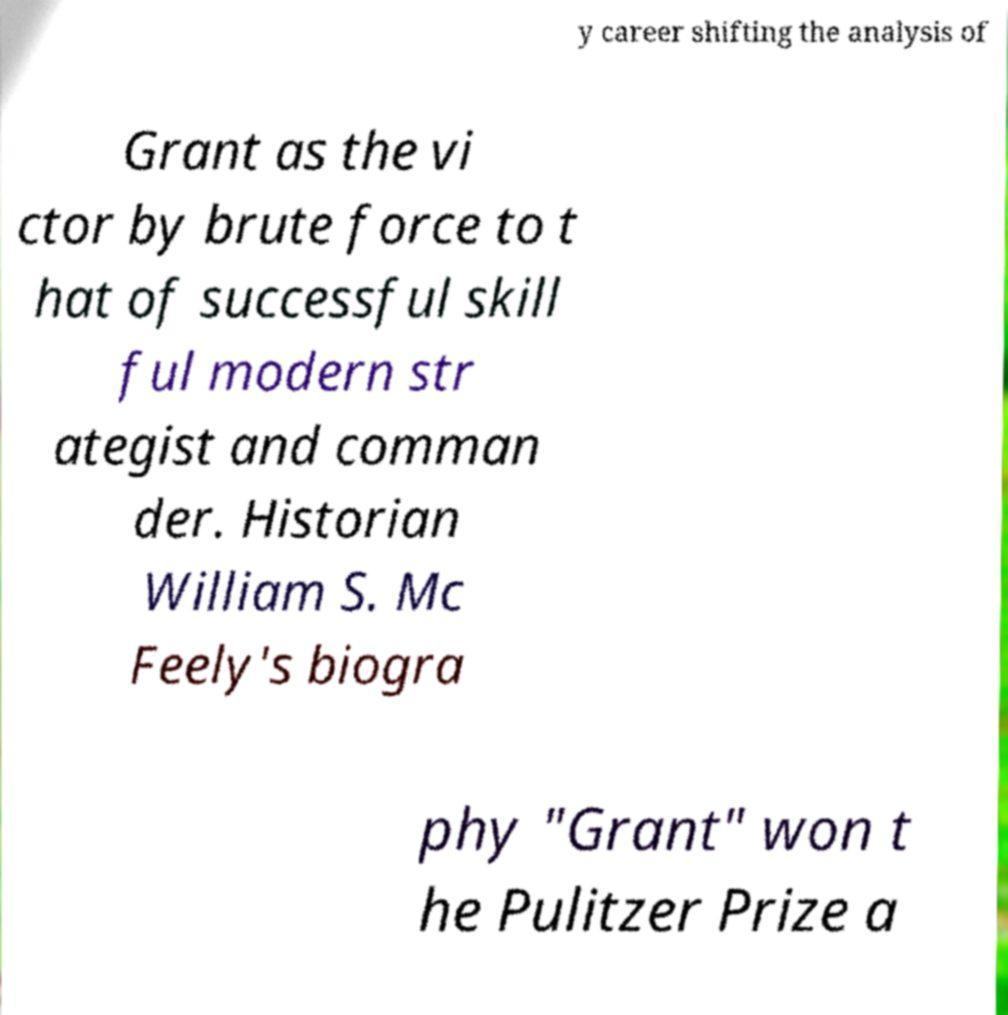I need the written content from this picture converted into text. Can you do that? y career shifting the analysis of Grant as the vi ctor by brute force to t hat of successful skill ful modern str ategist and comman der. Historian William S. Mc Feely's biogra phy "Grant" won t he Pulitzer Prize a 